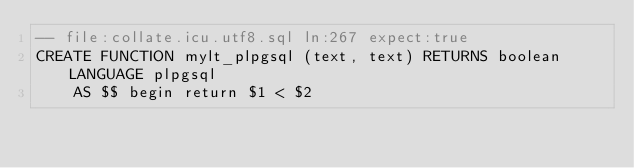<code> <loc_0><loc_0><loc_500><loc_500><_SQL_>-- file:collate.icu.utf8.sql ln:267 expect:true
CREATE FUNCTION mylt_plpgsql (text, text) RETURNS boolean LANGUAGE plpgsql
    AS $$ begin return $1 < $2
</code> 